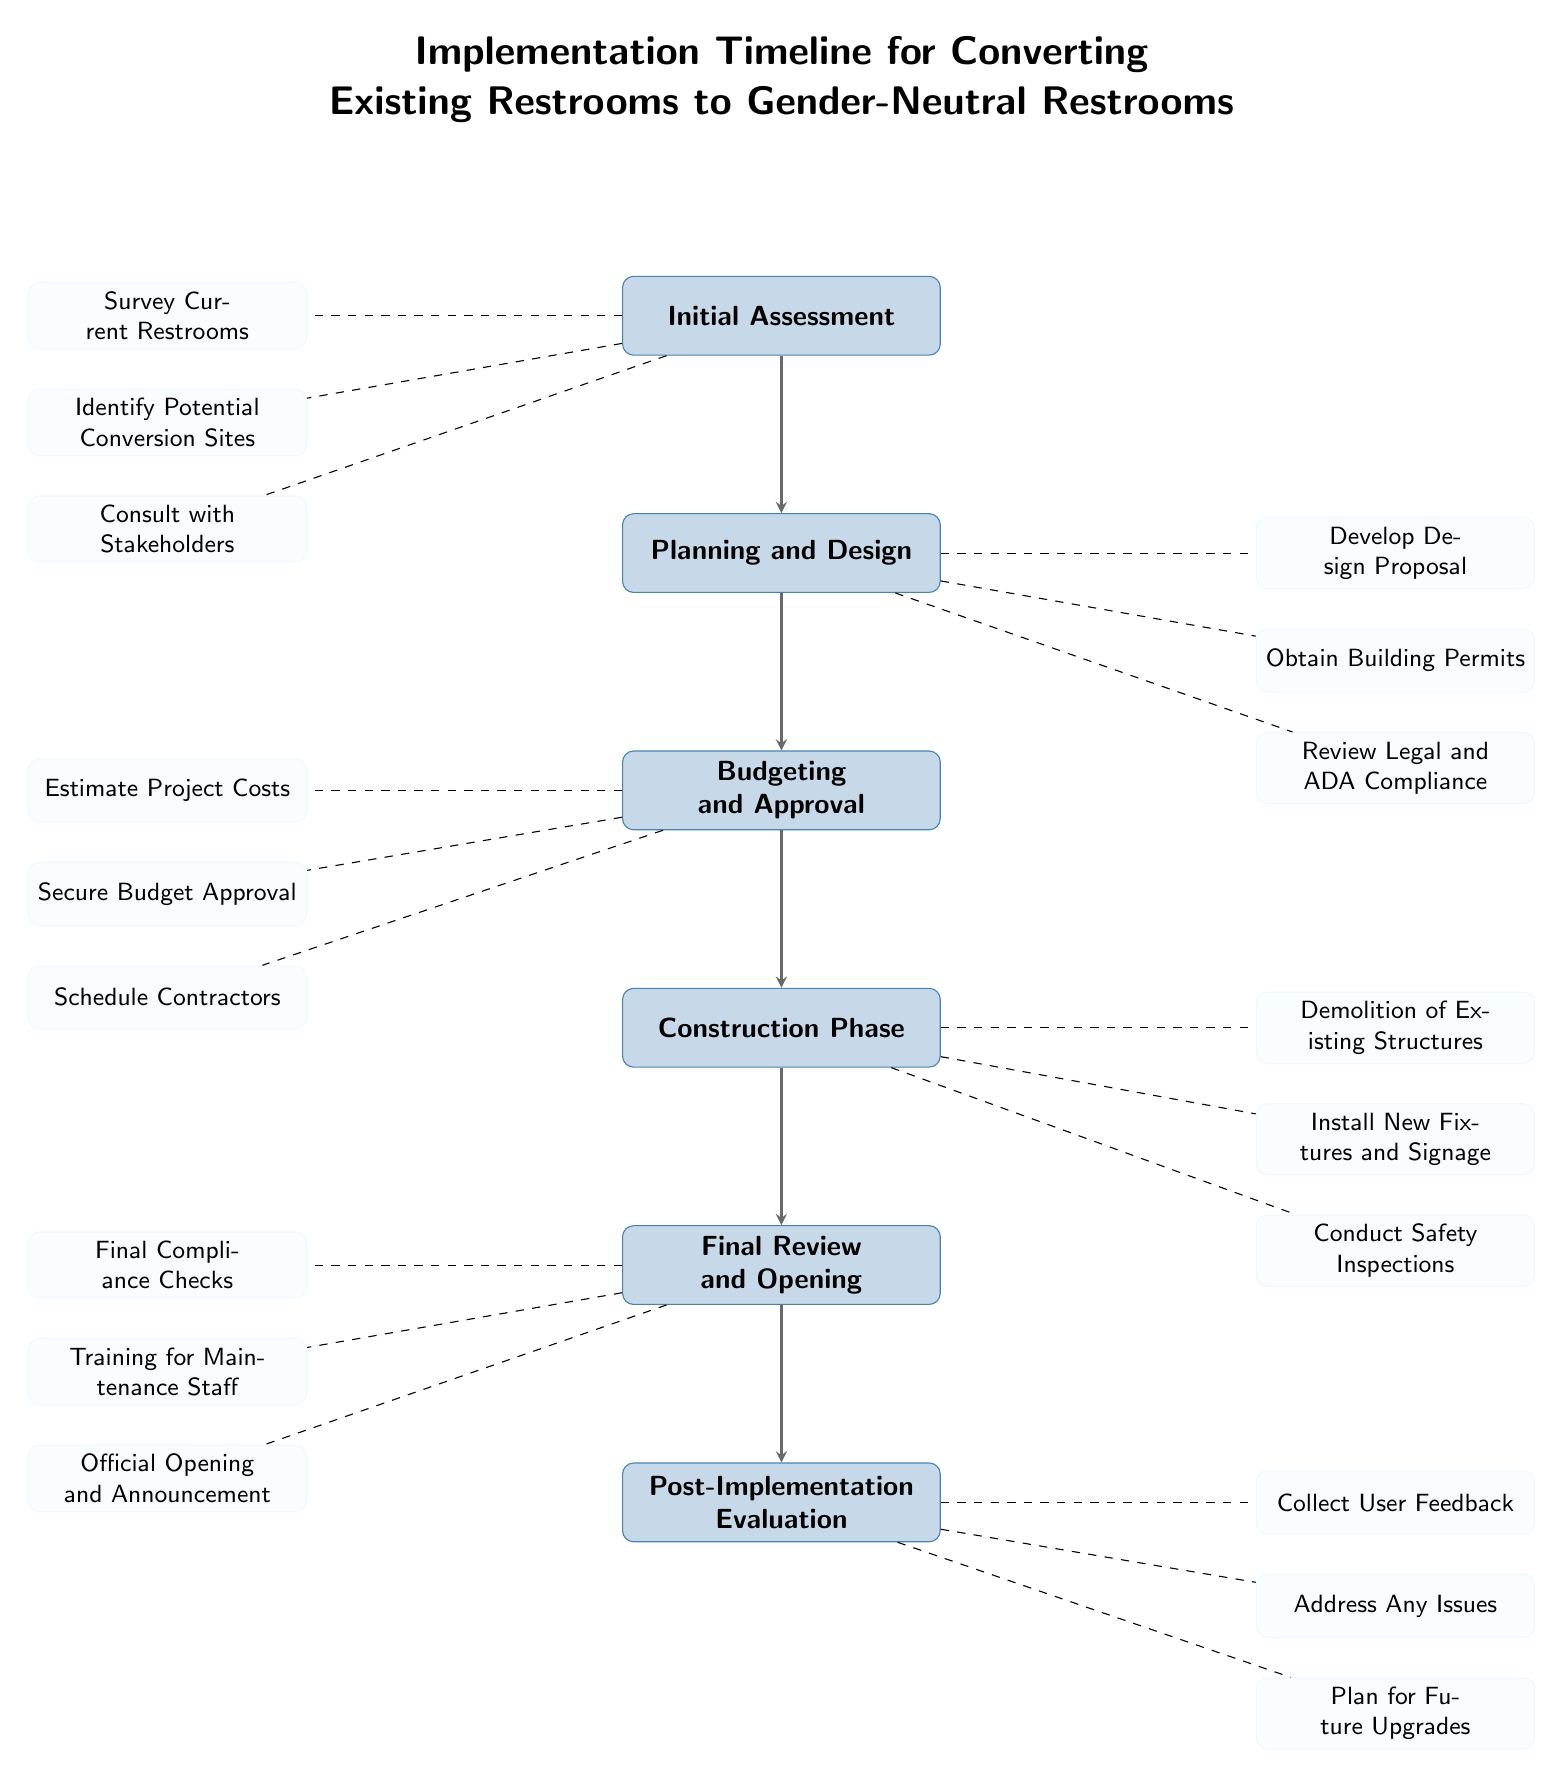What's the first milestone in the diagram? The first milestone is labeled as "Initial Assessment" in the diagram. This can be identified as it is the top-most milestone box.
Answer: Initial Assessment How many tasks are associated with the "Planning and Design" milestone? There are three tasks listed under the "Planning and Design" milestone: Develop Design Proposal, Obtain Building Permits, and Review Legal and ADA Compliance. Counting these gives a total of three tasks.
Answer: 3 What is the last milestone listed in the diagram? The last milestone is labeled as "Post-Implementation Evaluation," which is the bottom-most milestone in the diagram.
Answer: Post-Implementation Evaluation Which milestone directly follows "Budgeting and Approval"? The milestone that directly follows "Budgeting and Approval" is "Construction Phase." This is determined by following the arrows in the diagram from the "Budgeting and Approval" box downward.
Answer: Construction Phase What types of tasks are listed under the "Final Review and Opening" milestone? The tasks under the "Final Review and Opening" milestone include: Final Compliance Checks, Training for Maintenance Staff, and Official Opening and Announcement. These tasks are directly connected to that milestone.
Answer: Final Compliance Checks, Training for Maintenance Staff, Official Opening and Announcement How many total milestones are presented in this diagram? There are a total of six milestones in the diagram, from "Initial Assessment" down to "Post-Implementation Evaluation." This is counted by counting each individual milestone box.
Answer: 6 What task is associated with the first milestone? The first milestone, which is "Initial Assessment," has three associated tasks: Survey Current Restrooms, Identify Potential Conversion Sites, and Consult with Stakeholders. The first task, which is the focus, is "Survey Current Restrooms."
Answer: Survey Current Restrooms Which task corresponds with the "Construction Phase" milestone? The tasks under the "Construction Phase" milestone include Demolition of Existing Structures, Install New Fixtures and Signage, and Conduct Safety Inspections. The first task is "Demolition of Existing Structures."
Answer: Demolition of Existing Structures What is the relationship between the "Final Review and Opening" and "Post-Implementation Evaluation" milestones? The relationship is sequential, where "Final Review and Opening" occurs before "Post-Implementation Evaluation." This is shown by the arrow connecting "Final Review and Opening" pointing directly to "Post-Implementation Evaluation."
Answer: Sequential relationship 